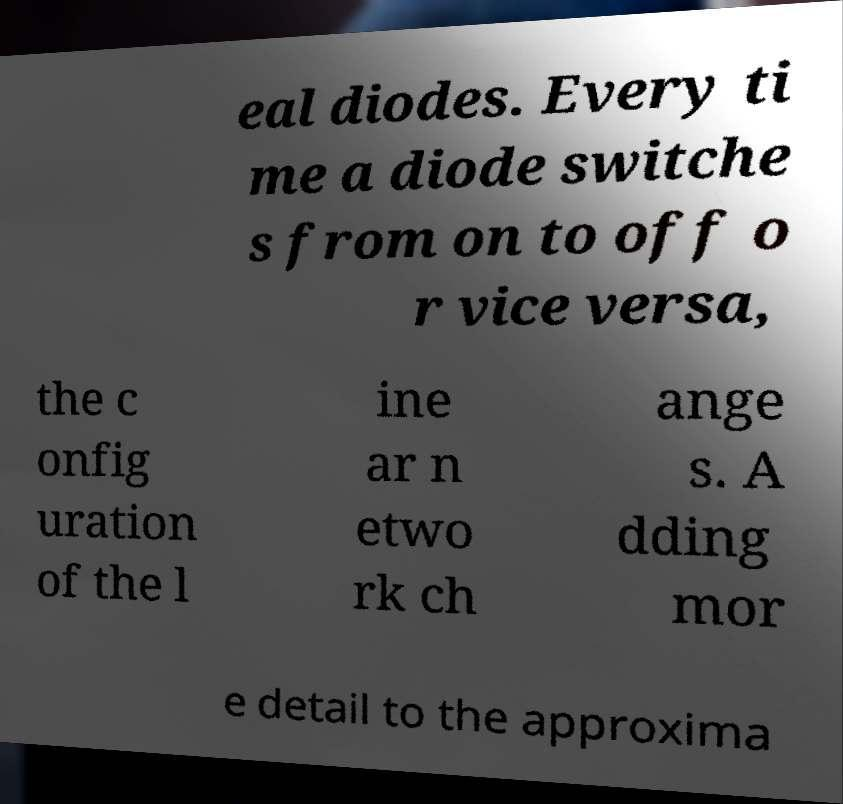Could you assist in decoding the text presented in this image and type it out clearly? eal diodes. Every ti me a diode switche s from on to off o r vice versa, the c onfig uration of the l ine ar n etwo rk ch ange s. A dding mor e detail to the approxima 